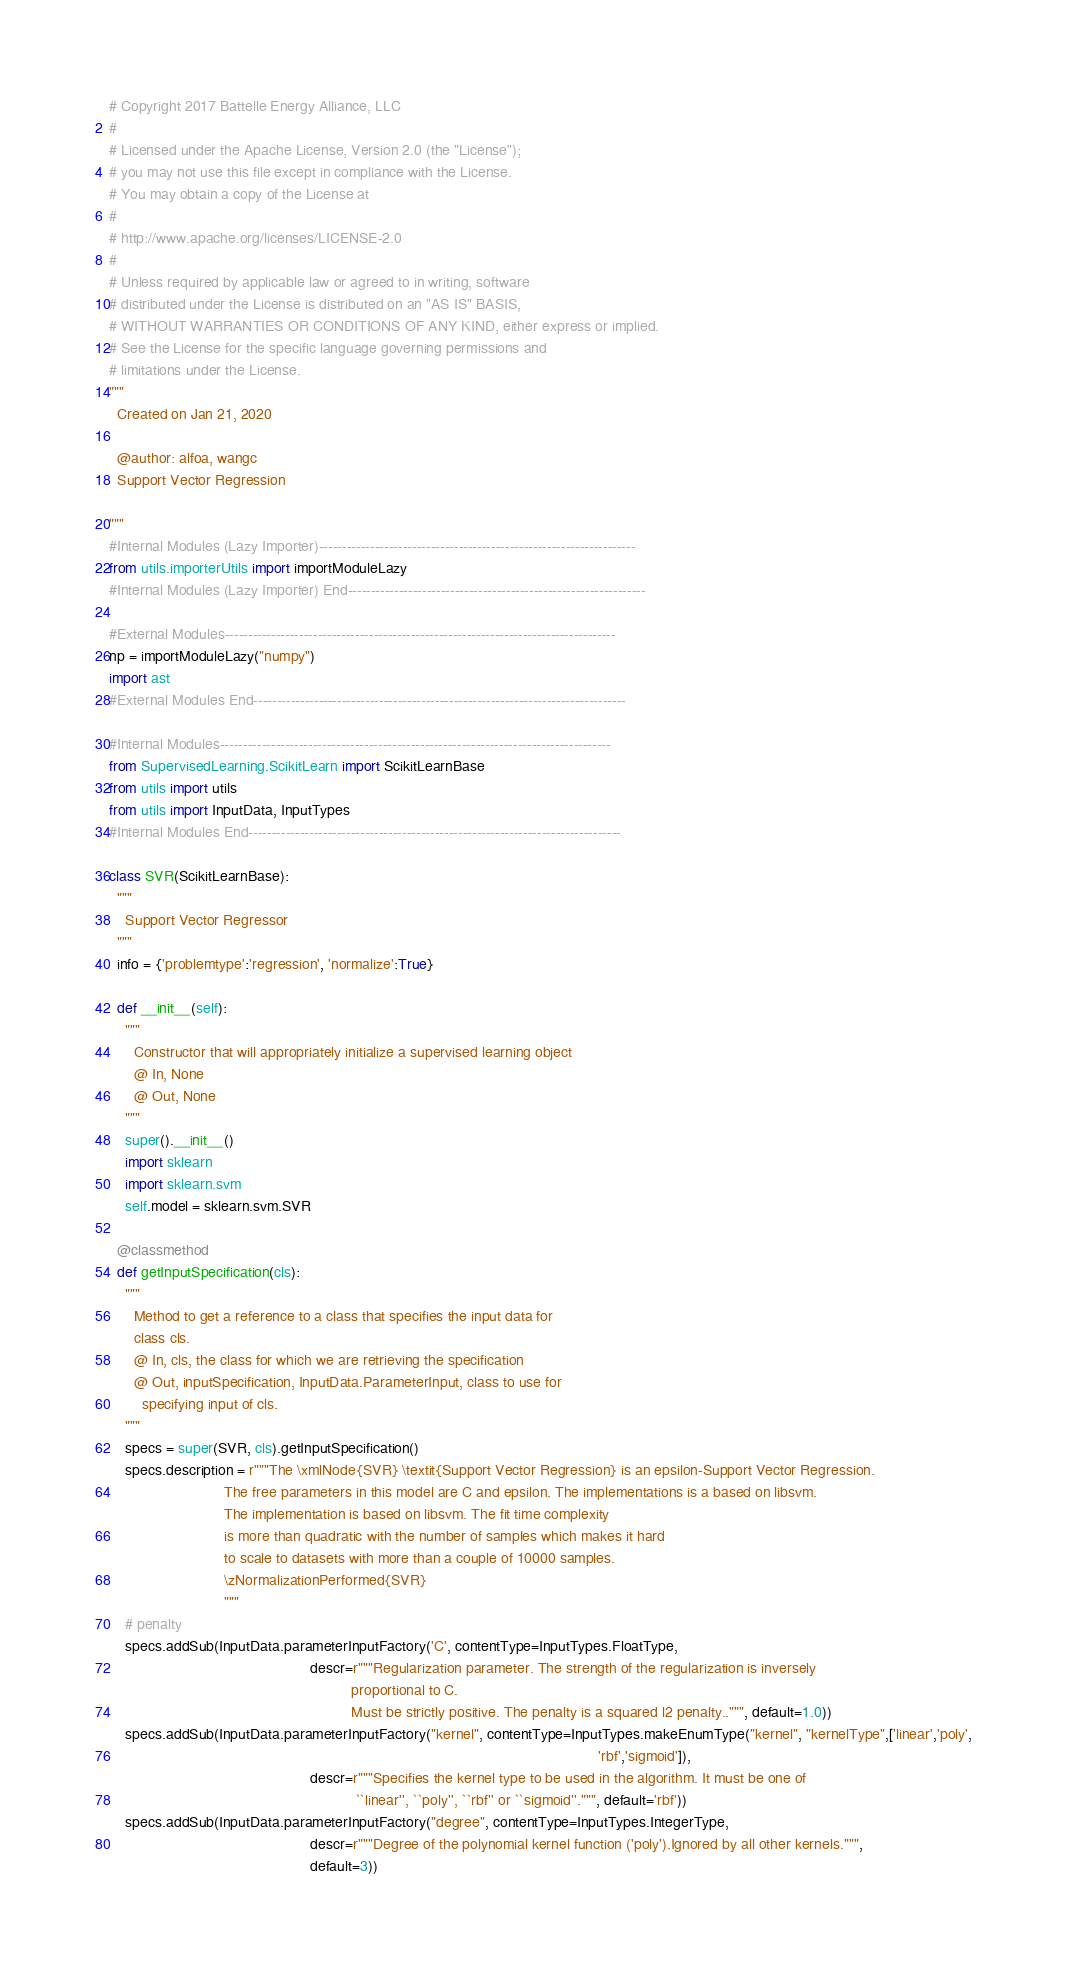Convert code to text. <code><loc_0><loc_0><loc_500><loc_500><_Python_># Copyright 2017 Battelle Energy Alliance, LLC
#
# Licensed under the Apache License, Version 2.0 (the "License");
# you may not use this file except in compliance with the License.
# You may obtain a copy of the License at
#
# http://www.apache.org/licenses/LICENSE-2.0
#
# Unless required by applicable law or agreed to in writing, software
# distributed under the License is distributed on an "AS IS" BASIS,
# WITHOUT WARRANTIES OR CONDITIONS OF ANY KIND, either express or implied.
# See the License for the specific language governing permissions and
# limitations under the License.
"""
  Created on Jan 21, 2020

  @author: alfoa, wangc
  Support Vector Regression

"""
#Internal Modules (Lazy Importer)--------------------------------------------------------------------
from utils.importerUtils import importModuleLazy
#Internal Modules (Lazy Importer) End----------------------------------------------------------------

#External Modules------------------------------------------------------------------------------------
np = importModuleLazy("numpy")
import ast
#External Modules End--------------------------------------------------------------------------------

#Internal Modules------------------------------------------------------------------------------------
from SupervisedLearning.ScikitLearn import ScikitLearnBase
from utils import utils
from utils import InputData, InputTypes
#Internal Modules End--------------------------------------------------------------------------------

class SVR(ScikitLearnBase):
  """
    Support Vector Regressor
  """
  info = {'problemtype':'regression', 'normalize':True}

  def __init__(self):
    """
      Constructor that will appropriately initialize a supervised learning object
      @ In, None
      @ Out, None
    """
    super().__init__()
    import sklearn
    import sklearn.svm
    self.model = sklearn.svm.SVR

  @classmethod
  def getInputSpecification(cls):
    """
      Method to get a reference to a class that specifies the input data for
      class cls.
      @ In, cls, the class for which we are retrieving the specification
      @ Out, inputSpecification, InputData.ParameterInput, class to use for
        specifying input of cls.
    """
    specs = super(SVR, cls).getInputSpecification()
    specs.description = r"""The \xmlNode{SVR} \textit{Support Vector Regression} is an epsilon-Support Vector Regression.
                            The free parameters in this model are C and epsilon. The implementations is a based on libsvm.
                            The implementation is based on libsvm. The fit time complexity
                            is more than quadratic with the number of samples which makes it hard
                            to scale to datasets with more than a couple of 10000 samples.
                            \zNormalizationPerformed{SVR}
                            """
    # penalty
    specs.addSub(InputData.parameterInputFactory('C', contentType=InputTypes.FloatType,
                                                 descr=r"""Regularization parameter. The strength of the regularization is inversely
                                                           proportional to C.
                                                           Must be strictly positive. The penalty is a squared l2 penalty..""", default=1.0))
    specs.addSub(InputData.parameterInputFactory("kernel", contentType=InputTypes.makeEnumType("kernel", "kernelType",['linear','poly',
                                                                                                                       'rbf','sigmoid']),
                                                 descr=r"""Specifies the kernel type to be used in the algorithm. It must be one of
                                                            ``linear'', ``poly'', ``rbf'' or ``sigmoid''.""", default='rbf'))
    specs.addSub(InputData.parameterInputFactory("degree", contentType=InputTypes.IntegerType,
                                                 descr=r"""Degree of the polynomial kernel function ('poly').Ignored by all other kernels.""",
                                                 default=3))</code> 